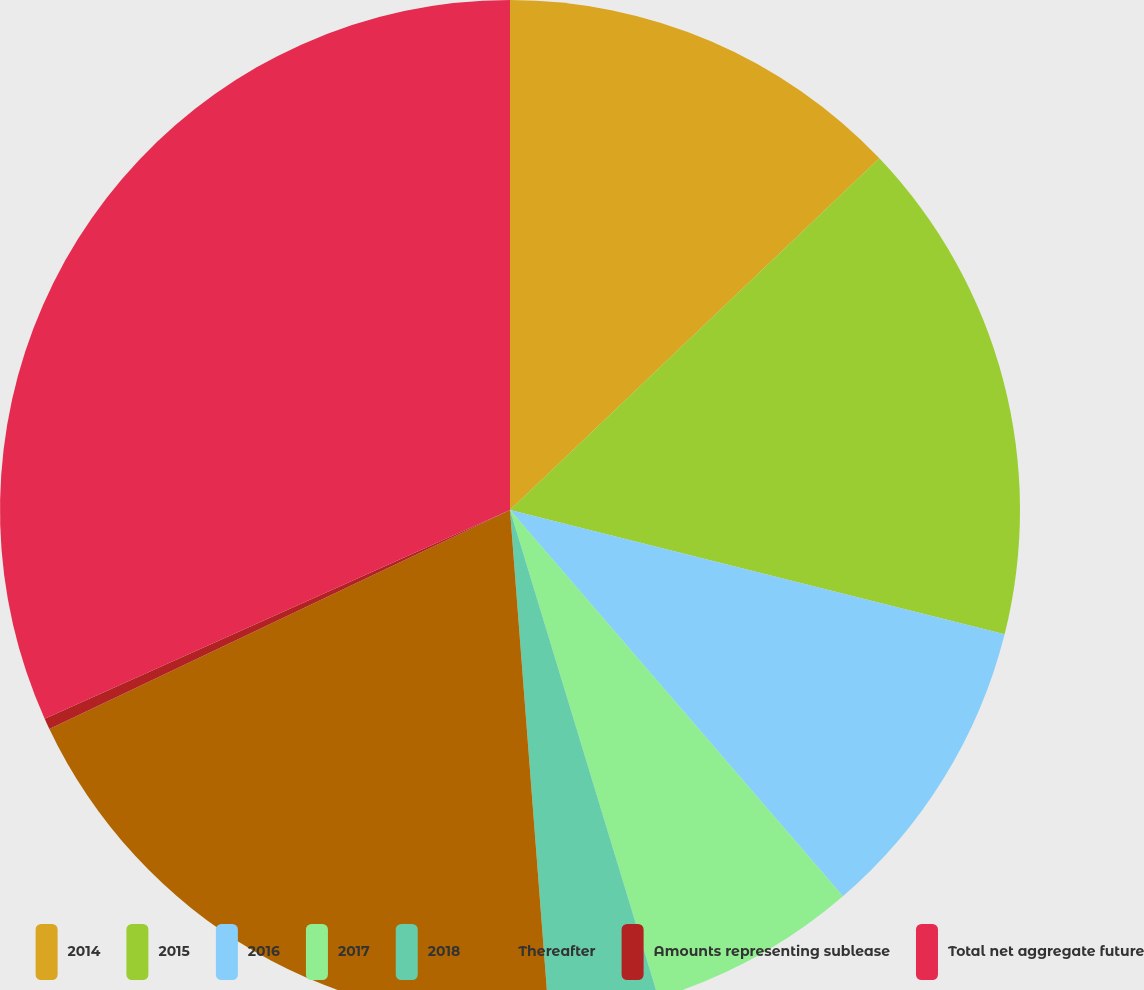<chart> <loc_0><loc_0><loc_500><loc_500><pie_chart><fcel>2014<fcel>2015<fcel>2016<fcel>2017<fcel>2018<fcel>Thereafter<fcel>Amounts representing sublease<fcel>Total net aggregate future<nl><fcel>12.89%<fcel>16.03%<fcel>9.76%<fcel>6.62%<fcel>3.48%<fcel>19.16%<fcel>0.35%<fcel>31.71%<nl></chart> 